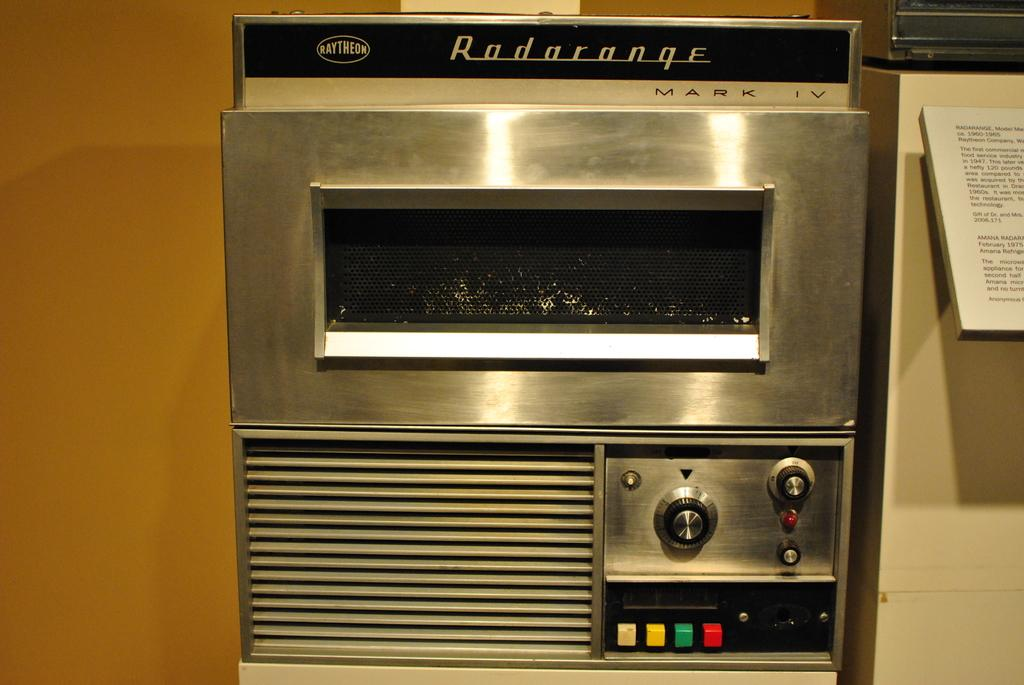<image>
Write a terse but informative summary of the picture. A old silver Radarange by Raytheon with four colorful buttons on the bottom 